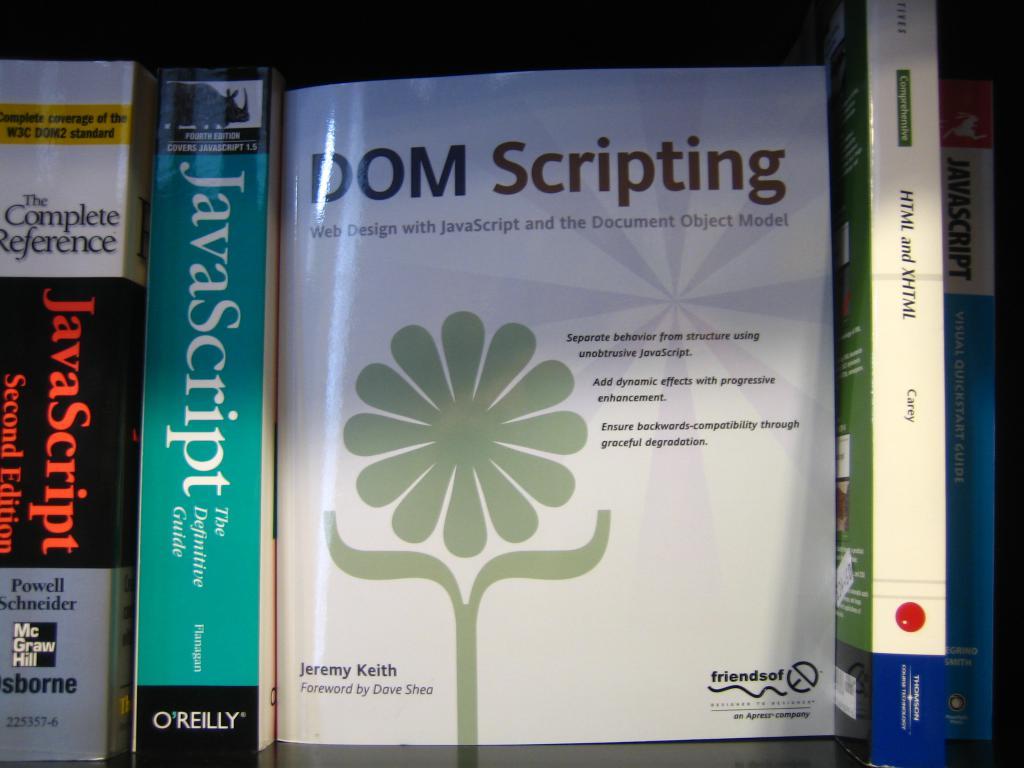What is the authors name who wrote dom scripting?
Your answer should be very brief. Jeremy keith. What is the book dom scripting about?
Offer a very short reply. Web design with javascript and the document object model. 